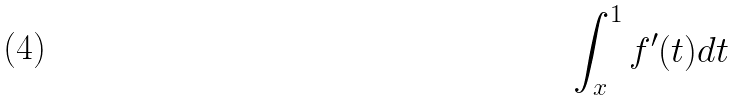Convert formula to latex. <formula><loc_0><loc_0><loc_500><loc_500>\int _ { x } ^ { 1 } f ^ { \prime } ( t ) d t</formula> 